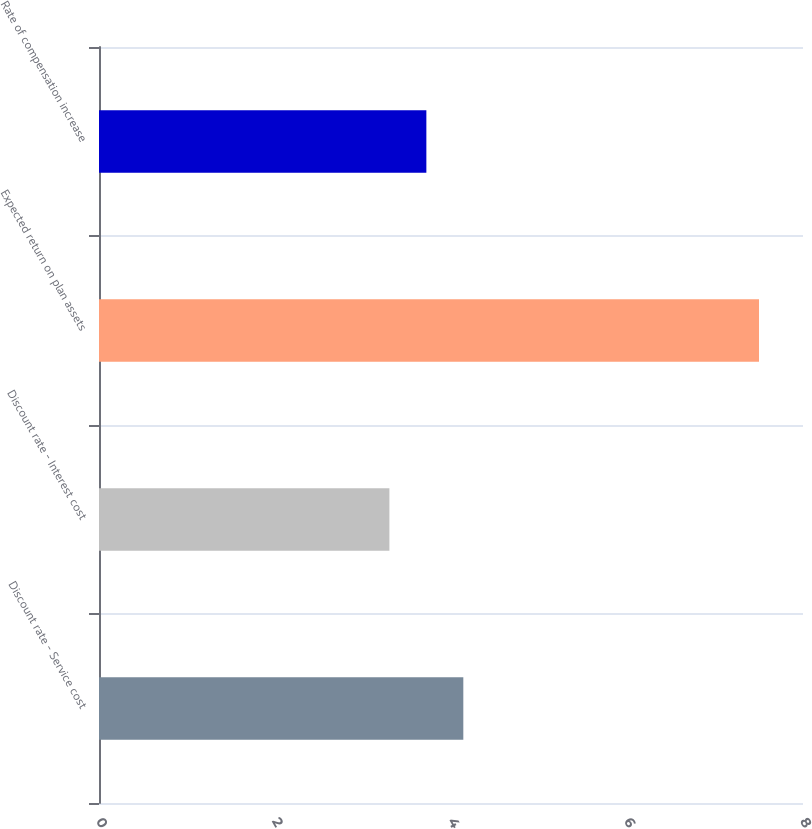<chart> <loc_0><loc_0><loc_500><loc_500><bar_chart><fcel>Discount rate - Service cost<fcel>Discount rate - Interest cost<fcel>Expected return on plan assets<fcel>Rate of compensation increase<nl><fcel>4.14<fcel>3.3<fcel>7.5<fcel>3.72<nl></chart> 